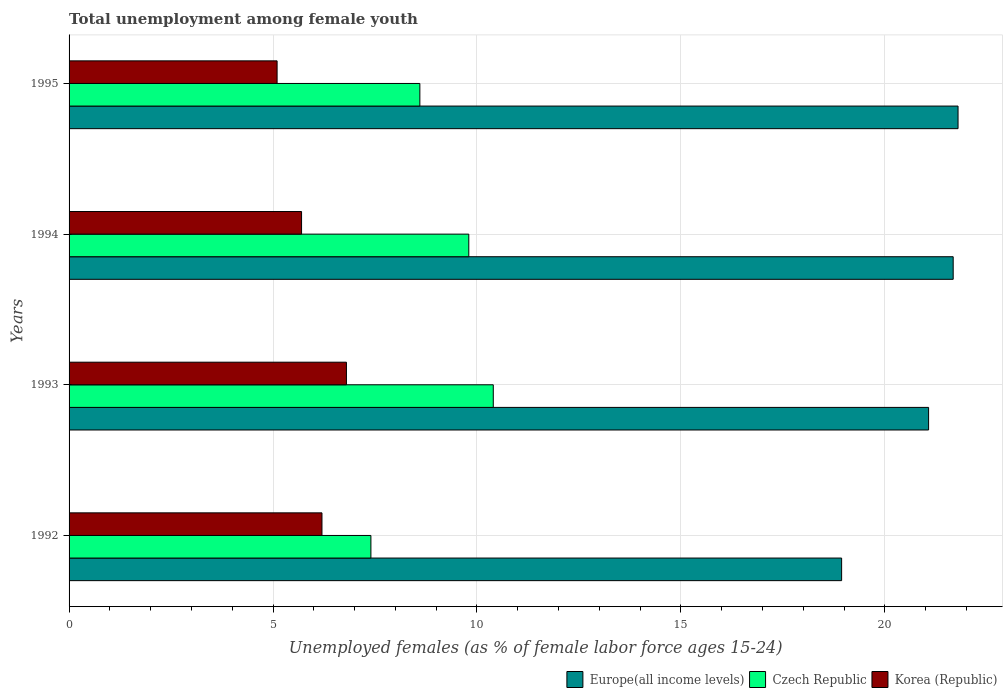How many different coloured bars are there?
Keep it short and to the point. 3. How many groups of bars are there?
Offer a very short reply. 4. How many bars are there on the 1st tick from the bottom?
Keep it short and to the point. 3. What is the label of the 2nd group of bars from the top?
Provide a succinct answer. 1994. What is the percentage of unemployed females in in Czech Republic in 1993?
Ensure brevity in your answer.  10.4. Across all years, what is the maximum percentage of unemployed females in in Czech Republic?
Offer a very short reply. 10.4. Across all years, what is the minimum percentage of unemployed females in in Europe(all income levels)?
Keep it short and to the point. 18.94. In which year was the percentage of unemployed females in in Korea (Republic) minimum?
Your answer should be compact. 1995. What is the total percentage of unemployed females in in Korea (Republic) in the graph?
Your answer should be compact. 23.8. What is the difference between the percentage of unemployed females in in Europe(all income levels) in 1993 and that in 1994?
Provide a succinct answer. -0.6. What is the difference between the percentage of unemployed females in in Korea (Republic) in 1994 and the percentage of unemployed females in in Europe(all income levels) in 1995?
Your response must be concise. -16.09. What is the average percentage of unemployed females in in Korea (Republic) per year?
Ensure brevity in your answer.  5.95. In the year 1992, what is the difference between the percentage of unemployed females in in Czech Republic and percentage of unemployed females in in Europe(all income levels)?
Keep it short and to the point. -11.54. In how many years, is the percentage of unemployed females in in Europe(all income levels) greater than 10 %?
Your answer should be very brief. 4. What is the ratio of the percentage of unemployed females in in Czech Republic in 1992 to that in 1993?
Provide a short and direct response. 0.71. Is the percentage of unemployed females in in Czech Republic in 1992 less than that in 1995?
Offer a very short reply. Yes. Is the difference between the percentage of unemployed females in in Czech Republic in 1993 and 1995 greater than the difference between the percentage of unemployed females in in Europe(all income levels) in 1993 and 1995?
Provide a succinct answer. Yes. What is the difference between the highest and the second highest percentage of unemployed females in in Europe(all income levels)?
Your answer should be very brief. 0.12. What is the difference between the highest and the lowest percentage of unemployed females in in Korea (Republic)?
Your answer should be very brief. 1.7. In how many years, is the percentage of unemployed females in in Korea (Republic) greater than the average percentage of unemployed females in in Korea (Republic) taken over all years?
Make the answer very short. 2. Is the sum of the percentage of unemployed females in in Czech Republic in 1992 and 1993 greater than the maximum percentage of unemployed females in in Korea (Republic) across all years?
Provide a succinct answer. Yes. What does the 1st bar from the top in 1993 represents?
Make the answer very short. Korea (Republic). What does the 2nd bar from the bottom in 1992 represents?
Provide a succinct answer. Czech Republic. How many bars are there?
Make the answer very short. 12. Are all the bars in the graph horizontal?
Offer a terse response. Yes. How many years are there in the graph?
Provide a short and direct response. 4. What is the difference between two consecutive major ticks on the X-axis?
Your answer should be very brief. 5. Does the graph contain any zero values?
Provide a succinct answer. No. How are the legend labels stacked?
Your answer should be compact. Horizontal. What is the title of the graph?
Offer a terse response. Total unemployment among female youth. What is the label or title of the X-axis?
Give a very brief answer. Unemployed females (as % of female labor force ages 15-24). What is the label or title of the Y-axis?
Make the answer very short. Years. What is the Unemployed females (as % of female labor force ages 15-24) in Europe(all income levels) in 1992?
Keep it short and to the point. 18.94. What is the Unemployed females (as % of female labor force ages 15-24) in Czech Republic in 1992?
Ensure brevity in your answer.  7.4. What is the Unemployed females (as % of female labor force ages 15-24) of Korea (Republic) in 1992?
Give a very brief answer. 6.2. What is the Unemployed females (as % of female labor force ages 15-24) in Europe(all income levels) in 1993?
Keep it short and to the point. 21.07. What is the Unemployed females (as % of female labor force ages 15-24) of Czech Republic in 1993?
Make the answer very short. 10.4. What is the Unemployed females (as % of female labor force ages 15-24) in Korea (Republic) in 1993?
Your response must be concise. 6.8. What is the Unemployed females (as % of female labor force ages 15-24) of Europe(all income levels) in 1994?
Give a very brief answer. 21.68. What is the Unemployed females (as % of female labor force ages 15-24) of Czech Republic in 1994?
Offer a terse response. 9.8. What is the Unemployed females (as % of female labor force ages 15-24) in Korea (Republic) in 1994?
Give a very brief answer. 5.7. What is the Unemployed females (as % of female labor force ages 15-24) of Europe(all income levels) in 1995?
Keep it short and to the point. 21.79. What is the Unemployed females (as % of female labor force ages 15-24) of Czech Republic in 1995?
Provide a succinct answer. 8.6. What is the Unemployed females (as % of female labor force ages 15-24) in Korea (Republic) in 1995?
Offer a very short reply. 5.1. Across all years, what is the maximum Unemployed females (as % of female labor force ages 15-24) of Europe(all income levels)?
Make the answer very short. 21.79. Across all years, what is the maximum Unemployed females (as % of female labor force ages 15-24) in Czech Republic?
Ensure brevity in your answer.  10.4. Across all years, what is the maximum Unemployed females (as % of female labor force ages 15-24) in Korea (Republic)?
Your answer should be very brief. 6.8. Across all years, what is the minimum Unemployed females (as % of female labor force ages 15-24) of Europe(all income levels)?
Provide a short and direct response. 18.94. Across all years, what is the minimum Unemployed females (as % of female labor force ages 15-24) in Czech Republic?
Provide a succinct answer. 7.4. Across all years, what is the minimum Unemployed females (as % of female labor force ages 15-24) of Korea (Republic)?
Offer a very short reply. 5.1. What is the total Unemployed females (as % of female labor force ages 15-24) of Europe(all income levels) in the graph?
Offer a very short reply. 83.48. What is the total Unemployed females (as % of female labor force ages 15-24) of Czech Republic in the graph?
Make the answer very short. 36.2. What is the total Unemployed females (as % of female labor force ages 15-24) of Korea (Republic) in the graph?
Your answer should be compact. 23.8. What is the difference between the Unemployed females (as % of female labor force ages 15-24) in Europe(all income levels) in 1992 and that in 1993?
Ensure brevity in your answer.  -2.13. What is the difference between the Unemployed females (as % of female labor force ages 15-24) in Czech Republic in 1992 and that in 1993?
Your response must be concise. -3. What is the difference between the Unemployed females (as % of female labor force ages 15-24) in Europe(all income levels) in 1992 and that in 1994?
Make the answer very short. -2.73. What is the difference between the Unemployed females (as % of female labor force ages 15-24) of Czech Republic in 1992 and that in 1994?
Your response must be concise. -2.4. What is the difference between the Unemployed females (as % of female labor force ages 15-24) in Korea (Republic) in 1992 and that in 1994?
Make the answer very short. 0.5. What is the difference between the Unemployed females (as % of female labor force ages 15-24) in Europe(all income levels) in 1992 and that in 1995?
Ensure brevity in your answer.  -2.85. What is the difference between the Unemployed females (as % of female labor force ages 15-24) of Czech Republic in 1992 and that in 1995?
Your answer should be compact. -1.2. What is the difference between the Unemployed females (as % of female labor force ages 15-24) of Korea (Republic) in 1992 and that in 1995?
Your response must be concise. 1.1. What is the difference between the Unemployed females (as % of female labor force ages 15-24) of Europe(all income levels) in 1993 and that in 1994?
Ensure brevity in your answer.  -0.6. What is the difference between the Unemployed females (as % of female labor force ages 15-24) in Czech Republic in 1993 and that in 1994?
Provide a short and direct response. 0.6. What is the difference between the Unemployed females (as % of female labor force ages 15-24) of Europe(all income levels) in 1993 and that in 1995?
Keep it short and to the point. -0.72. What is the difference between the Unemployed females (as % of female labor force ages 15-24) of Czech Republic in 1993 and that in 1995?
Give a very brief answer. 1.8. What is the difference between the Unemployed females (as % of female labor force ages 15-24) of Europe(all income levels) in 1994 and that in 1995?
Offer a terse response. -0.12. What is the difference between the Unemployed females (as % of female labor force ages 15-24) in Czech Republic in 1994 and that in 1995?
Your answer should be very brief. 1.2. What is the difference between the Unemployed females (as % of female labor force ages 15-24) in Europe(all income levels) in 1992 and the Unemployed females (as % of female labor force ages 15-24) in Czech Republic in 1993?
Your answer should be compact. 8.54. What is the difference between the Unemployed females (as % of female labor force ages 15-24) of Europe(all income levels) in 1992 and the Unemployed females (as % of female labor force ages 15-24) of Korea (Republic) in 1993?
Your answer should be very brief. 12.14. What is the difference between the Unemployed females (as % of female labor force ages 15-24) of Europe(all income levels) in 1992 and the Unemployed females (as % of female labor force ages 15-24) of Czech Republic in 1994?
Give a very brief answer. 9.14. What is the difference between the Unemployed females (as % of female labor force ages 15-24) of Europe(all income levels) in 1992 and the Unemployed females (as % of female labor force ages 15-24) of Korea (Republic) in 1994?
Your response must be concise. 13.24. What is the difference between the Unemployed females (as % of female labor force ages 15-24) in Czech Republic in 1992 and the Unemployed females (as % of female labor force ages 15-24) in Korea (Republic) in 1994?
Offer a very short reply. 1.7. What is the difference between the Unemployed females (as % of female labor force ages 15-24) of Europe(all income levels) in 1992 and the Unemployed females (as % of female labor force ages 15-24) of Czech Republic in 1995?
Offer a terse response. 10.34. What is the difference between the Unemployed females (as % of female labor force ages 15-24) in Europe(all income levels) in 1992 and the Unemployed females (as % of female labor force ages 15-24) in Korea (Republic) in 1995?
Give a very brief answer. 13.84. What is the difference between the Unemployed females (as % of female labor force ages 15-24) in Czech Republic in 1992 and the Unemployed females (as % of female labor force ages 15-24) in Korea (Republic) in 1995?
Provide a short and direct response. 2.3. What is the difference between the Unemployed females (as % of female labor force ages 15-24) in Europe(all income levels) in 1993 and the Unemployed females (as % of female labor force ages 15-24) in Czech Republic in 1994?
Give a very brief answer. 11.27. What is the difference between the Unemployed females (as % of female labor force ages 15-24) in Europe(all income levels) in 1993 and the Unemployed females (as % of female labor force ages 15-24) in Korea (Republic) in 1994?
Your answer should be compact. 15.37. What is the difference between the Unemployed females (as % of female labor force ages 15-24) of Czech Republic in 1993 and the Unemployed females (as % of female labor force ages 15-24) of Korea (Republic) in 1994?
Your answer should be very brief. 4.7. What is the difference between the Unemployed females (as % of female labor force ages 15-24) of Europe(all income levels) in 1993 and the Unemployed females (as % of female labor force ages 15-24) of Czech Republic in 1995?
Provide a succinct answer. 12.47. What is the difference between the Unemployed females (as % of female labor force ages 15-24) of Europe(all income levels) in 1993 and the Unemployed females (as % of female labor force ages 15-24) of Korea (Republic) in 1995?
Offer a very short reply. 15.97. What is the difference between the Unemployed females (as % of female labor force ages 15-24) of Czech Republic in 1993 and the Unemployed females (as % of female labor force ages 15-24) of Korea (Republic) in 1995?
Give a very brief answer. 5.3. What is the difference between the Unemployed females (as % of female labor force ages 15-24) in Europe(all income levels) in 1994 and the Unemployed females (as % of female labor force ages 15-24) in Czech Republic in 1995?
Offer a very short reply. 13.08. What is the difference between the Unemployed females (as % of female labor force ages 15-24) in Europe(all income levels) in 1994 and the Unemployed females (as % of female labor force ages 15-24) in Korea (Republic) in 1995?
Make the answer very short. 16.58. What is the difference between the Unemployed females (as % of female labor force ages 15-24) in Czech Republic in 1994 and the Unemployed females (as % of female labor force ages 15-24) in Korea (Republic) in 1995?
Your response must be concise. 4.7. What is the average Unemployed females (as % of female labor force ages 15-24) in Europe(all income levels) per year?
Your answer should be compact. 20.87. What is the average Unemployed females (as % of female labor force ages 15-24) in Czech Republic per year?
Your answer should be very brief. 9.05. What is the average Unemployed females (as % of female labor force ages 15-24) in Korea (Republic) per year?
Provide a short and direct response. 5.95. In the year 1992, what is the difference between the Unemployed females (as % of female labor force ages 15-24) of Europe(all income levels) and Unemployed females (as % of female labor force ages 15-24) of Czech Republic?
Keep it short and to the point. 11.54. In the year 1992, what is the difference between the Unemployed females (as % of female labor force ages 15-24) in Europe(all income levels) and Unemployed females (as % of female labor force ages 15-24) in Korea (Republic)?
Offer a very short reply. 12.74. In the year 1993, what is the difference between the Unemployed females (as % of female labor force ages 15-24) in Europe(all income levels) and Unemployed females (as % of female labor force ages 15-24) in Czech Republic?
Provide a short and direct response. 10.67. In the year 1993, what is the difference between the Unemployed females (as % of female labor force ages 15-24) of Europe(all income levels) and Unemployed females (as % of female labor force ages 15-24) of Korea (Republic)?
Your answer should be compact. 14.27. In the year 1993, what is the difference between the Unemployed females (as % of female labor force ages 15-24) in Czech Republic and Unemployed females (as % of female labor force ages 15-24) in Korea (Republic)?
Your response must be concise. 3.6. In the year 1994, what is the difference between the Unemployed females (as % of female labor force ages 15-24) of Europe(all income levels) and Unemployed females (as % of female labor force ages 15-24) of Czech Republic?
Your response must be concise. 11.88. In the year 1994, what is the difference between the Unemployed females (as % of female labor force ages 15-24) of Europe(all income levels) and Unemployed females (as % of female labor force ages 15-24) of Korea (Republic)?
Offer a very short reply. 15.98. In the year 1994, what is the difference between the Unemployed females (as % of female labor force ages 15-24) of Czech Republic and Unemployed females (as % of female labor force ages 15-24) of Korea (Republic)?
Give a very brief answer. 4.1. In the year 1995, what is the difference between the Unemployed females (as % of female labor force ages 15-24) of Europe(all income levels) and Unemployed females (as % of female labor force ages 15-24) of Czech Republic?
Give a very brief answer. 13.19. In the year 1995, what is the difference between the Unemployed females (as % of female labor force ages 15-24) in Europe(all income levels) and Unemployed females (as % of female labor force ages 15-24) in Korea (Republic)?
Ensure brevity in your answer.  16.69. In the year 1995, what is the difference between the Unemployed females (as % of female labor force ages 15-24) in Czech Republic and Unemployed females (as % of female labor force ages 15-24) in Korea (Republic)?
Make the answer very short. 3.5. What is the ratio of the Unemployed females (as % of female labor force ages 15-24) in Europe(all income levels) in 1992 to that in 1993?
Ensure brevity in your answer.  0.9. What is the ratio of the Unemployed females (as % of female labor force ages 15-24) of Czech Republic in 1992 to that in 1993?
Your answer should be compact. 0.71. What is the ratio of the Unemployed females (as % of female labor force ages 15-24) in Korea (Republic) in 1992 to that in 1993?
Your answer should be compact. 0.91. What is the ratio of the Unemployed females (as % of female labor force ages 15-24) of Europe(all income levels) in 1992 to that in 1994?
Provide a succinct answer. 0.87. What is the ratio of the Unemployed females (as % of female labor force ages 15-24) in Czech Republic in 1992 to that in 1994?
Give a very brief answer. 0.76. What is the ratio of the Unemployed females (as % of female labor force ages 15-24) of Korea (Republic) in 1992 to that in 1994?
Ensure brevity in your answer.  1.09. What is the ratio of the Unemployed females (as % of female labor force ages 15-24) of Europe(all income levels) in 1992 to that in 1995?
Your answer should be very brief. 0.87. What is the ratio of the Unemployed females (as % of female labor force ages 15-24) in Czech Republic in 1992 to that in 1995?
Give a very brief answer. 0.86. What is the ratio of the Unemployed females (as % of female labor force ages 15-24) in Korea (Republic) in 1992 to that in 1995?
Your answer should be compact. 1.22. What is the ratio of the Unemployed females (as % of female labor force ages 15-24) in Europe(all income levels) in 1993 to that in 1994?
Offer a terse response. 0.97. What is the ratio of the Unemployed females (as % of female labor force ages 15-24) in Czech Republic in 1993 to that in 1994?
Provide a succinct answer. 1.06. What is the ratio of the Unemployed females (as % of female labor force ages 15-24) of Korea (Republic) in 1993 to that in 1994?
Provide a succinct answer. 1.19. What is the ratio of the Unemployed females (as % of female labor force ages 15-24) of Europe(all income levels) in 1993 to that in 1995?
Keep it short and to the point. 0.97. What is the ratio of the Unemployed females (as % of female labor force ages 15-24) in Czech Republic in 1993 to that in 1995?
Your response must be concise. 1.21. What is the ratio of the Unemployed females (as % of female labor force ages 15-24) of Korea (Republic) in 1993 to that in 1995?
Keep it short and to the point. 1.33. What is the ratio of the Unemployed females (as % of female labor force ages 15-24) in Czech Republic in 1994 to that in 1995?
Ensure brevity in your answer.  1.14. What is the ratio of the Unemployed females (as % of female labor force ages 15-24) of Korea (Republic) in 1994 to that in 1995?
Provide a short and direct response. 1.12. What is the difference between the highest and the second highest Unemployed females (as % of female labor force ages 15-24) in Europe(all income levels)?
Provide a short and direct response. 0.12. What is the difference between the highest and the lowest Unemployed females (as % of female labor force ages 15-24) of Europe(all income levels)?
Keep it short and to the point. 2.85. What is the difference between the highest and the lowest Unemployed females (as % of female labor force ages 15-24) in Korea (Republic)?
Keep it short and to the point. 1.7. 